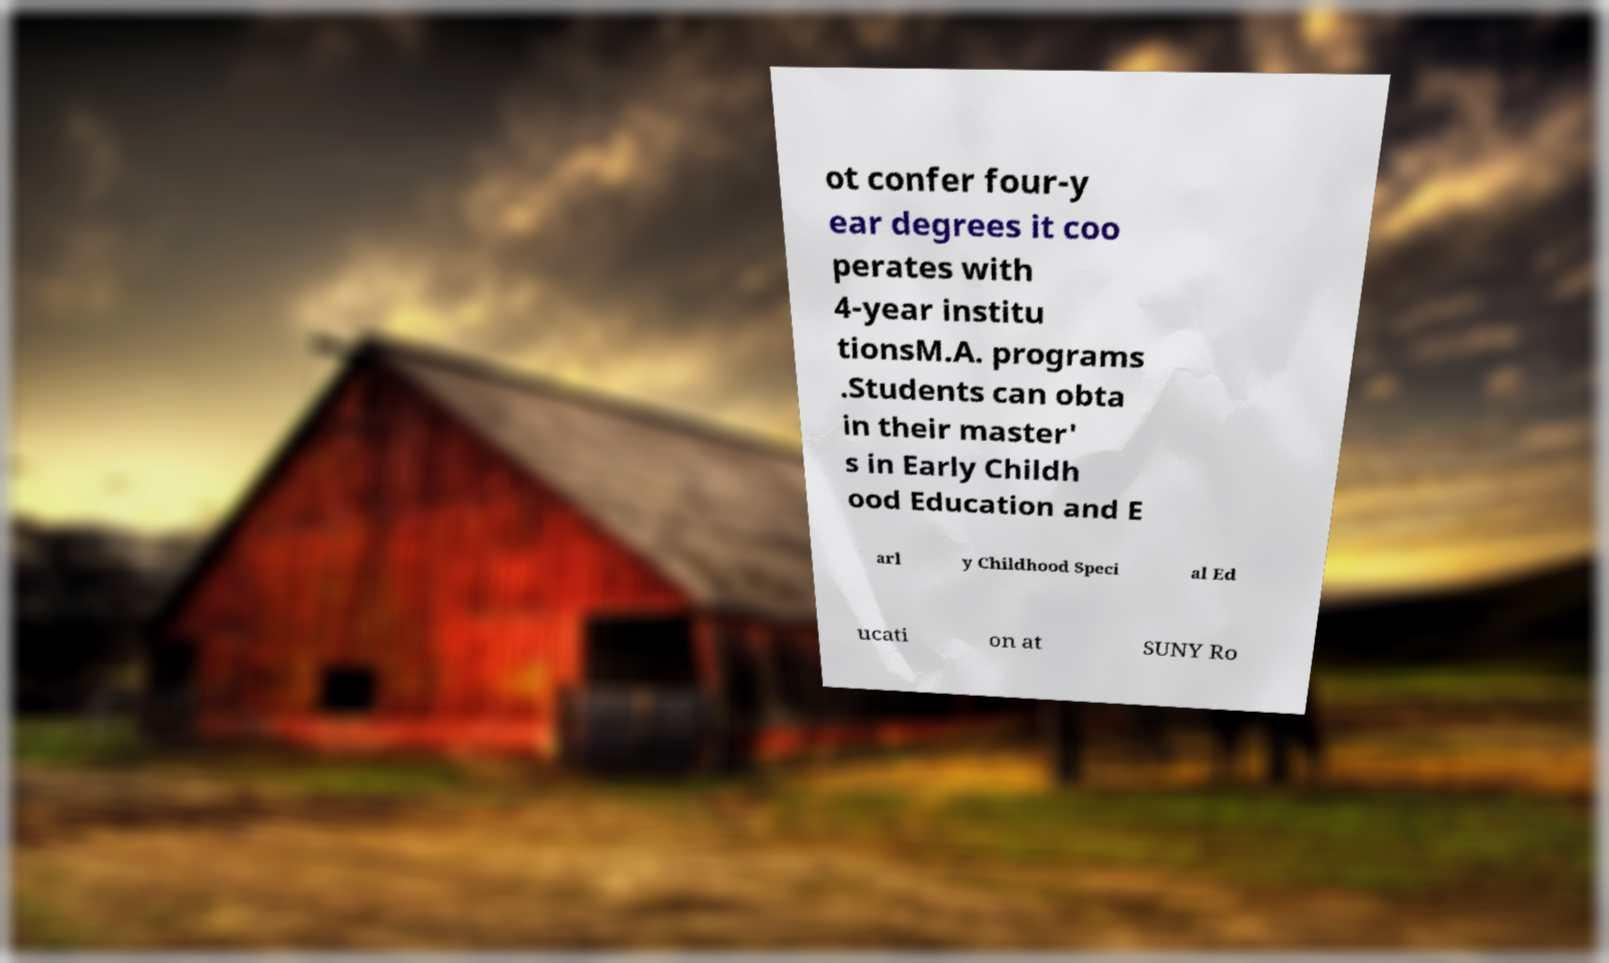Can you read and provide the text displayed in the image?This photo seems to have some interesting text. Can you extract and type it out for me? ot confer four-y ear degrees it coo perates with 4-year institu tionsM.A. programs .Students can obta in their master' s in Early Childh ood Education and E arl y Childhood Speci al Ed ucati on at SUNY Ro 